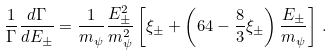<formula> <loc_0><loc_0><loc_500><loc_500>\frac { 1 } { \Gamma } \frac { d \Gamma } { d E _ { \pm } } = \frac { 1 } { m _ { \psi } } \frac { E _ { \pm } ^ { 2 } } { m _ { \psi } ^ { 2 } } \left [ \xi _ { \pm } + \left ( 6 4 - \frac { 8 } { 3 } \xi _ { \pm } \right ) \frac { E _ { \pm } } { m _ { \psi } } \right ] \, .</formula> 